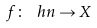<formula> <loc_0><loc_0><loc_500><loc_500>f \colon \ h n \rightarrow X</formula> 